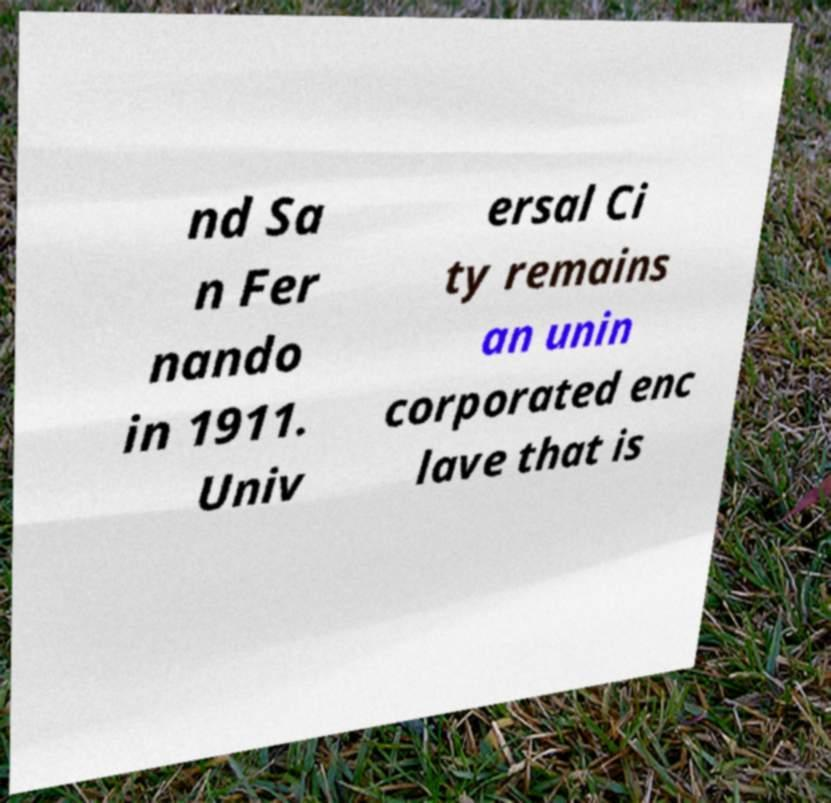I need the written content from this picture converted into text. Can you do that? nd Sa n Fer nando in 1911. Univ ersal Ci ty remains an unin corporated enc lave that is 